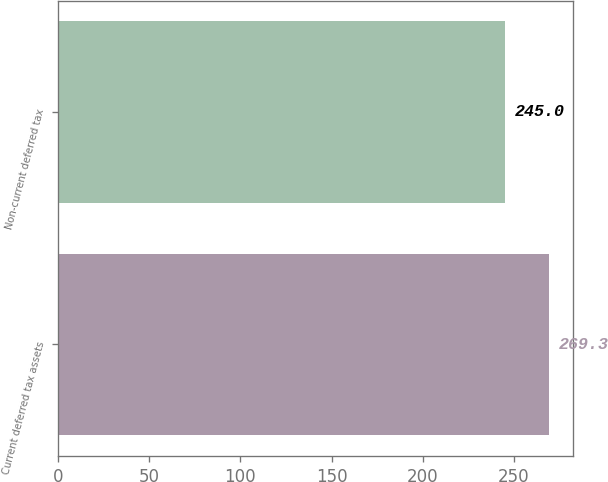Convert chart to OTSL. <chart><loc_0><loc_0><loc_500><loc_500><bar_chart><fcel>Current deferred tax assets<fcel>Non-current deferred tax<nl><fcel>269.3<fcel>245<nl></chart> 